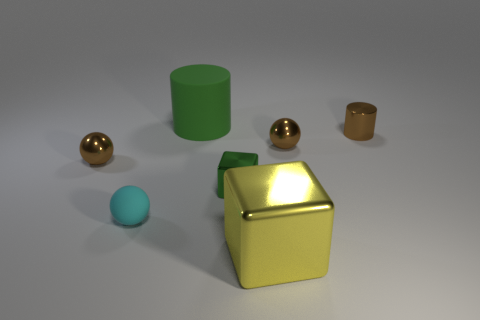What number of spheres are large matte objects or tiny matte things?
Your response must be concise. 1. What shape is the large yellow thing?
Give a very brief answer. Cube. There is a large shiny thing; are there any large green rubber cylinders in front of it?
Offer a terse response. No. Are the tiny green thing and the large thing that is in front of the small cylinder made of the same material?
Your answer should be compact. Yes. There is a small brown metallic thing to the left of the large green cylinder; does it have the same shape as the large green object?
Your answer should be compact. No. How many brown cylinders are the same material as the tiny cube?
Offer a very short reply. 1. How many things are tiny spheres that are on the left side of the cyan rubber thing or tiny green shiny blocks?
Ensure brevity in your answer.  2. What is the size of the yellow metallic thing?
Keep it short and to the point. Large. There is a tiny brown ball that is in front of the sphere to the right of the large metal cube; what is its material?
Make the answer very short. Metal. There is a rubber thing that is left of the matte cylinder; does it have the same size as the green rubber cylinder?
Your response must be concise. No. 